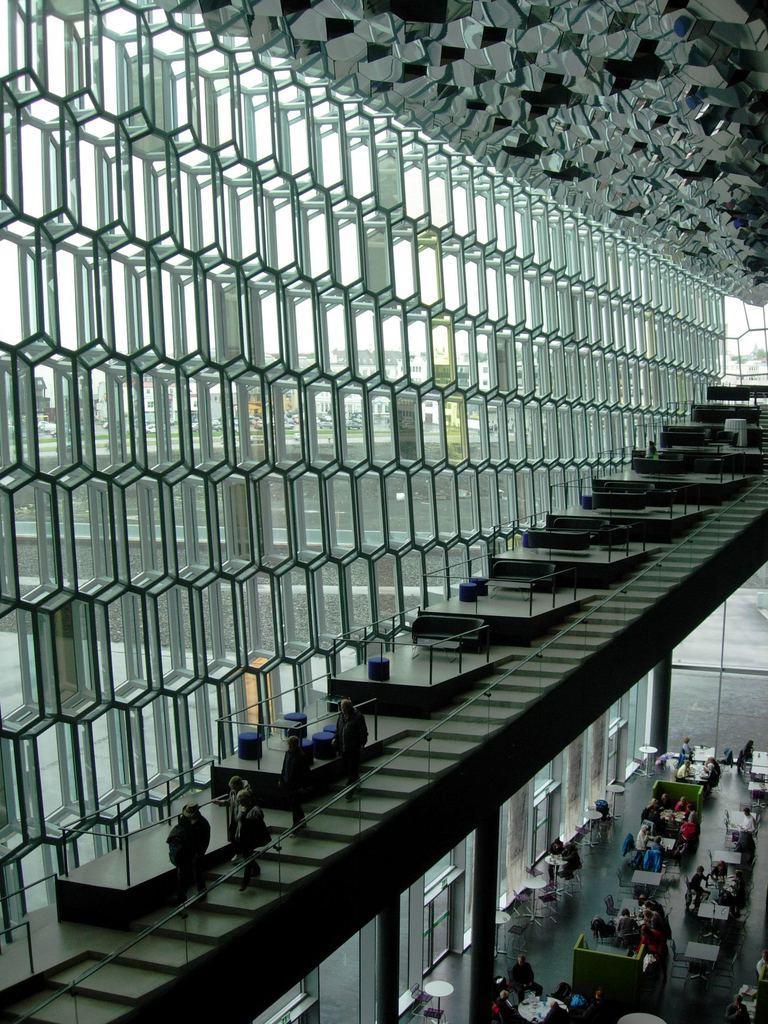Can you describe this image briefly? In this picture we can see a few people sitting on the chair. There are some tables visible in the bottom right. We can see a few stairs, glasses, chairs and a few people are walking on these stairs. There are a some glass objects on the left side. Through these glass objects, we can see a few buildings in the background. 